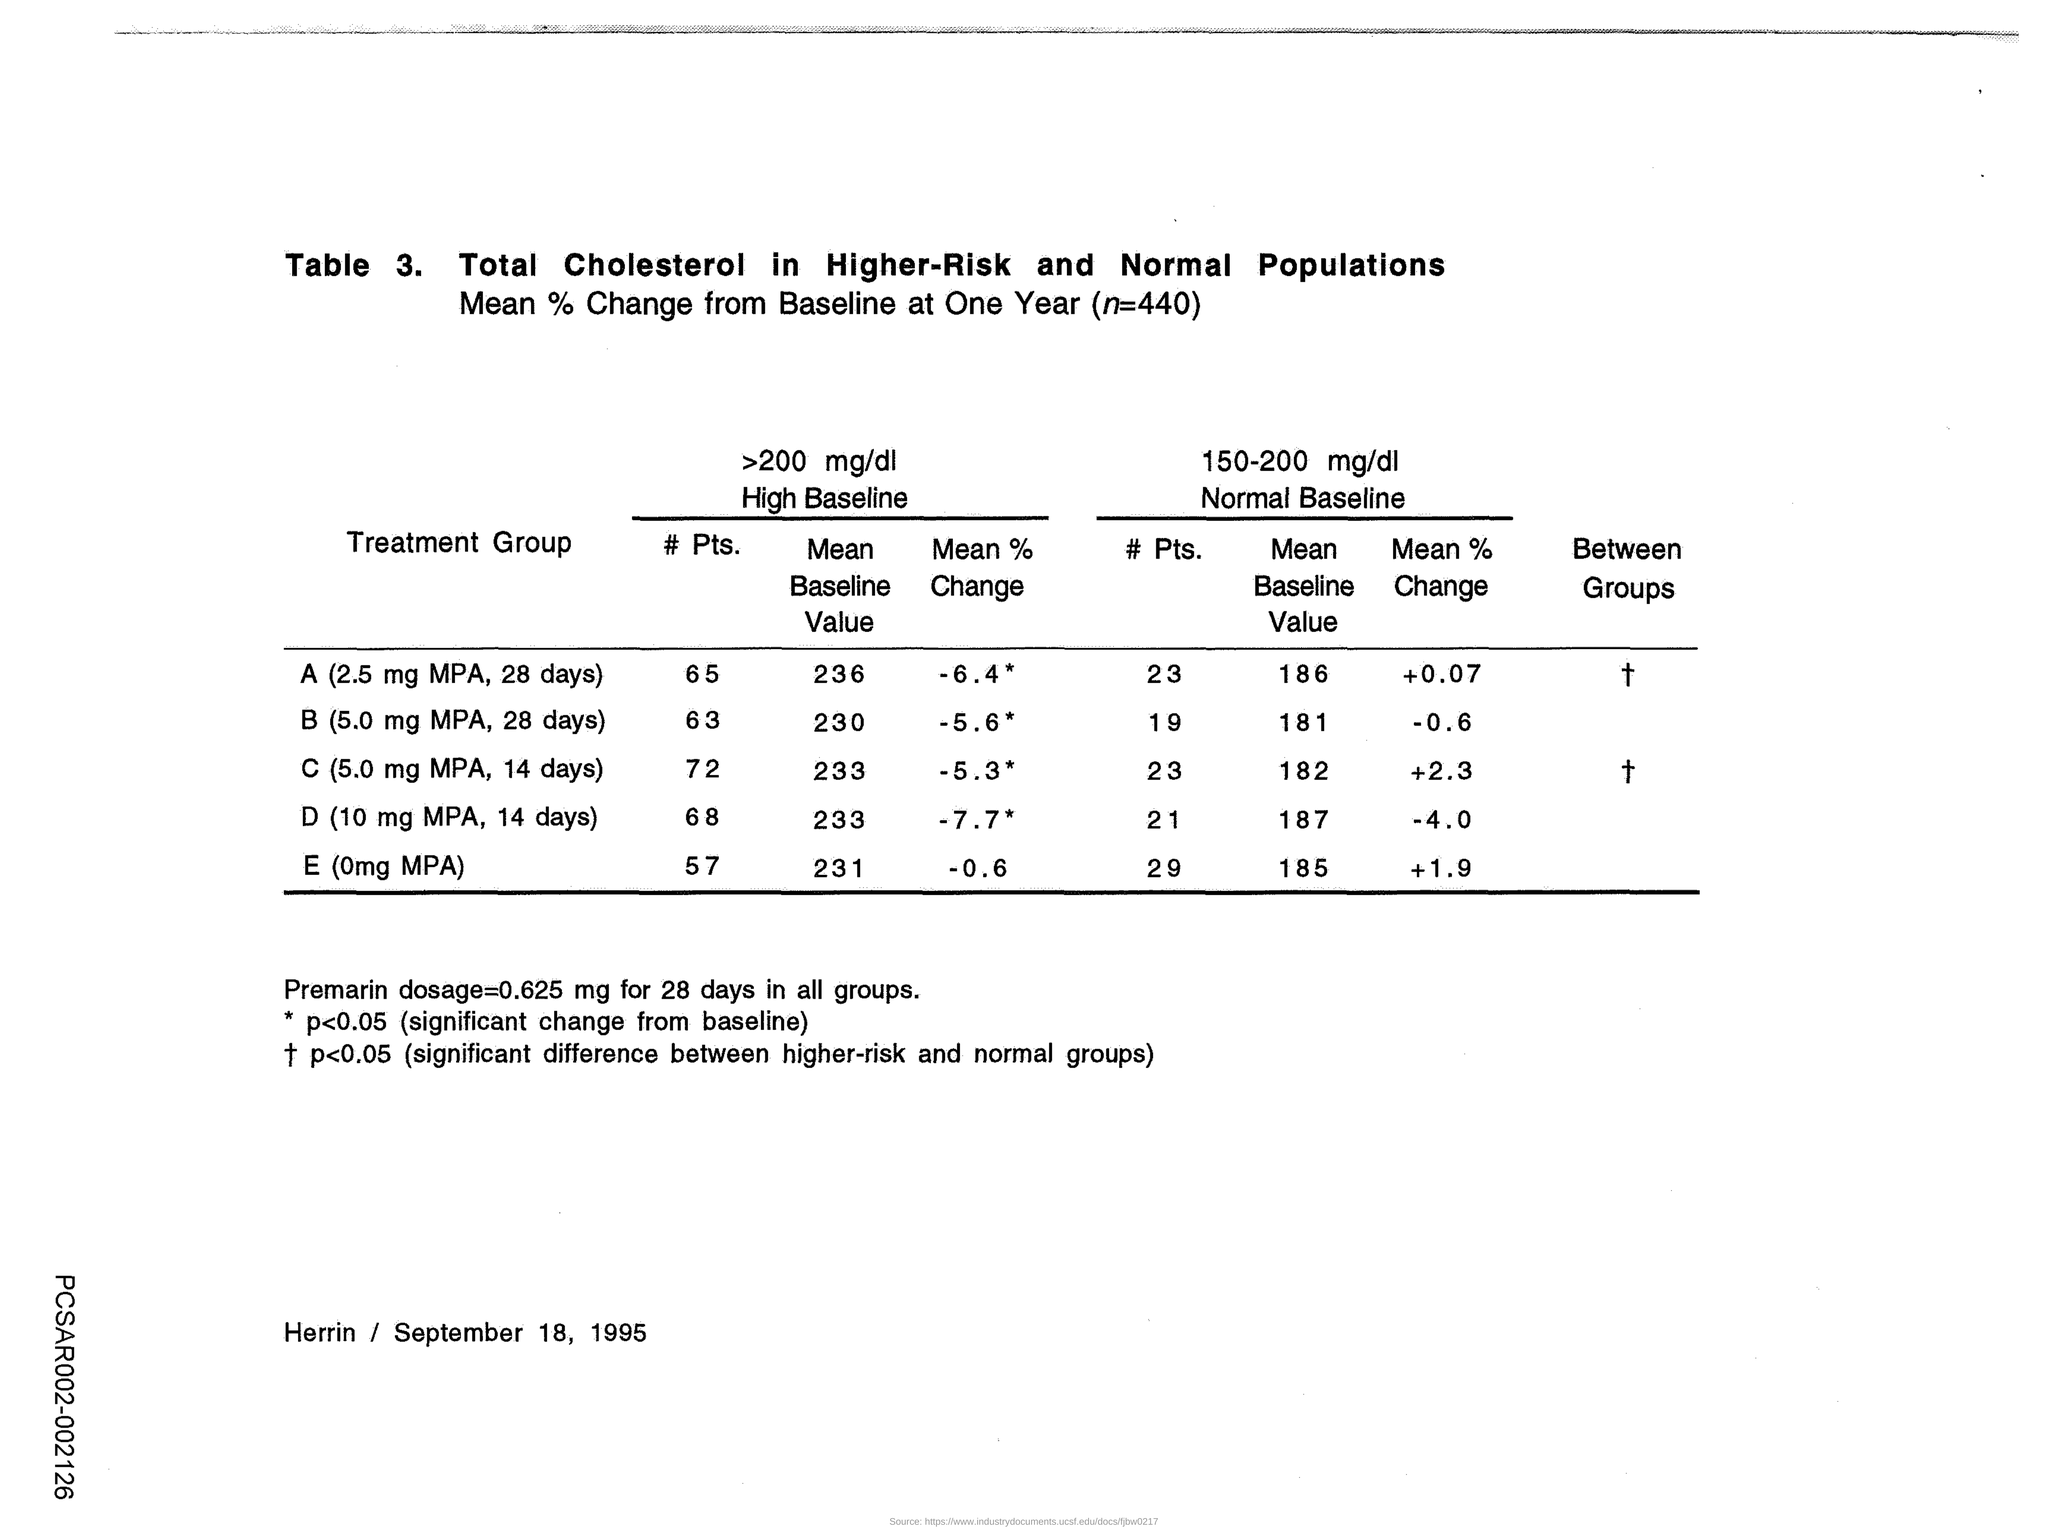What is the >200 mg/dl High Baseline - Mean baseline Value for treatment group A?
Your response must be concise. 236. What is the >200 mg/dl High Baseline - Mean baseline Value for treatment group B?
Your response must be concise. 230. What is the >200 mg/dl High Baseline - Mean baseline Value for treatment group C??
Make the answer very short. 233. What is the >200 mg/dl High Baseline - Mean baseline Value for treatment group D?
Offer a very short reply. 233. What is the >200 mg/dl High Baseline - Mean baseline Value for treatment group E?
Your answer should be very brief. 231. What is the >200 mg/dl High Baseline - Mean % Change for treatment group A?
Give a very brief answer. -6.4 *. What is the >200 mg/dl High Baseline - Mean % Change for treatment group B?
Offer a very short reply. -5.6. What is the >200 mg/dl High Baseline - Mean % Change for treatment group C?
Provide a short and direct response. -5.3. What is the >200 mg/dl High Baseline - Mean % Change for treatment group D?
Make the answer very short. -7.7. What is the >200 mg/dl High Baseline - Mean % Change for treatment group E?
Provide a succinct answer. -0.6. 